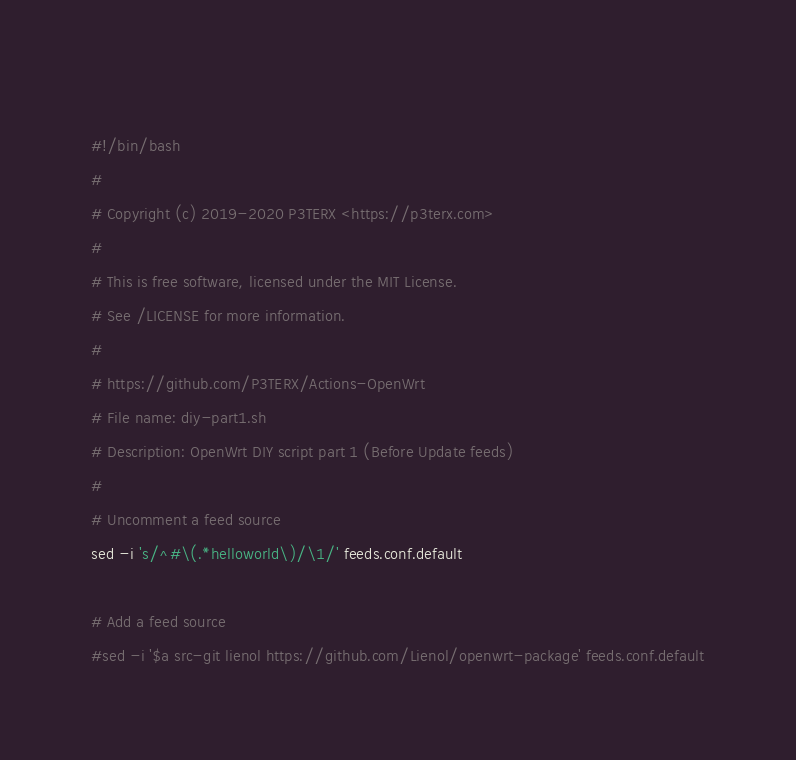<code> <loc_0><loc_0><loc_500><loc_500><_Bash_> 
#!/bin/bash
#
# Copyright (c) 2019-2020 P3TERX <https://p3terx.com>
#
# This is free software, licensed under the MIT License.
# See /LICENSE for more information.
#
# https://github.com/P3TERX/Actions-OpenWrt
# File name: diy-part1.sh
# Description: OpenWrt DIY script part 1 (Before Update feeds)
#
# Uncomment a feed source
sed -i 's/^#\(.*helloworld\)/\1/' feeds.conf.default

# Add a feed source
#sed -i '$a src-git lienol https://github.com/Lienol/openwrt-package' feeds.conf.default
</code> 